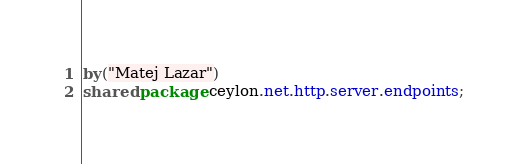Convert code to text. <code><loc_0><loc_0><loc_500><loc_500><_Ceylon_>by("Matej Lazar")
shared package ceylon.net.http.server.endpoints;
</code> 